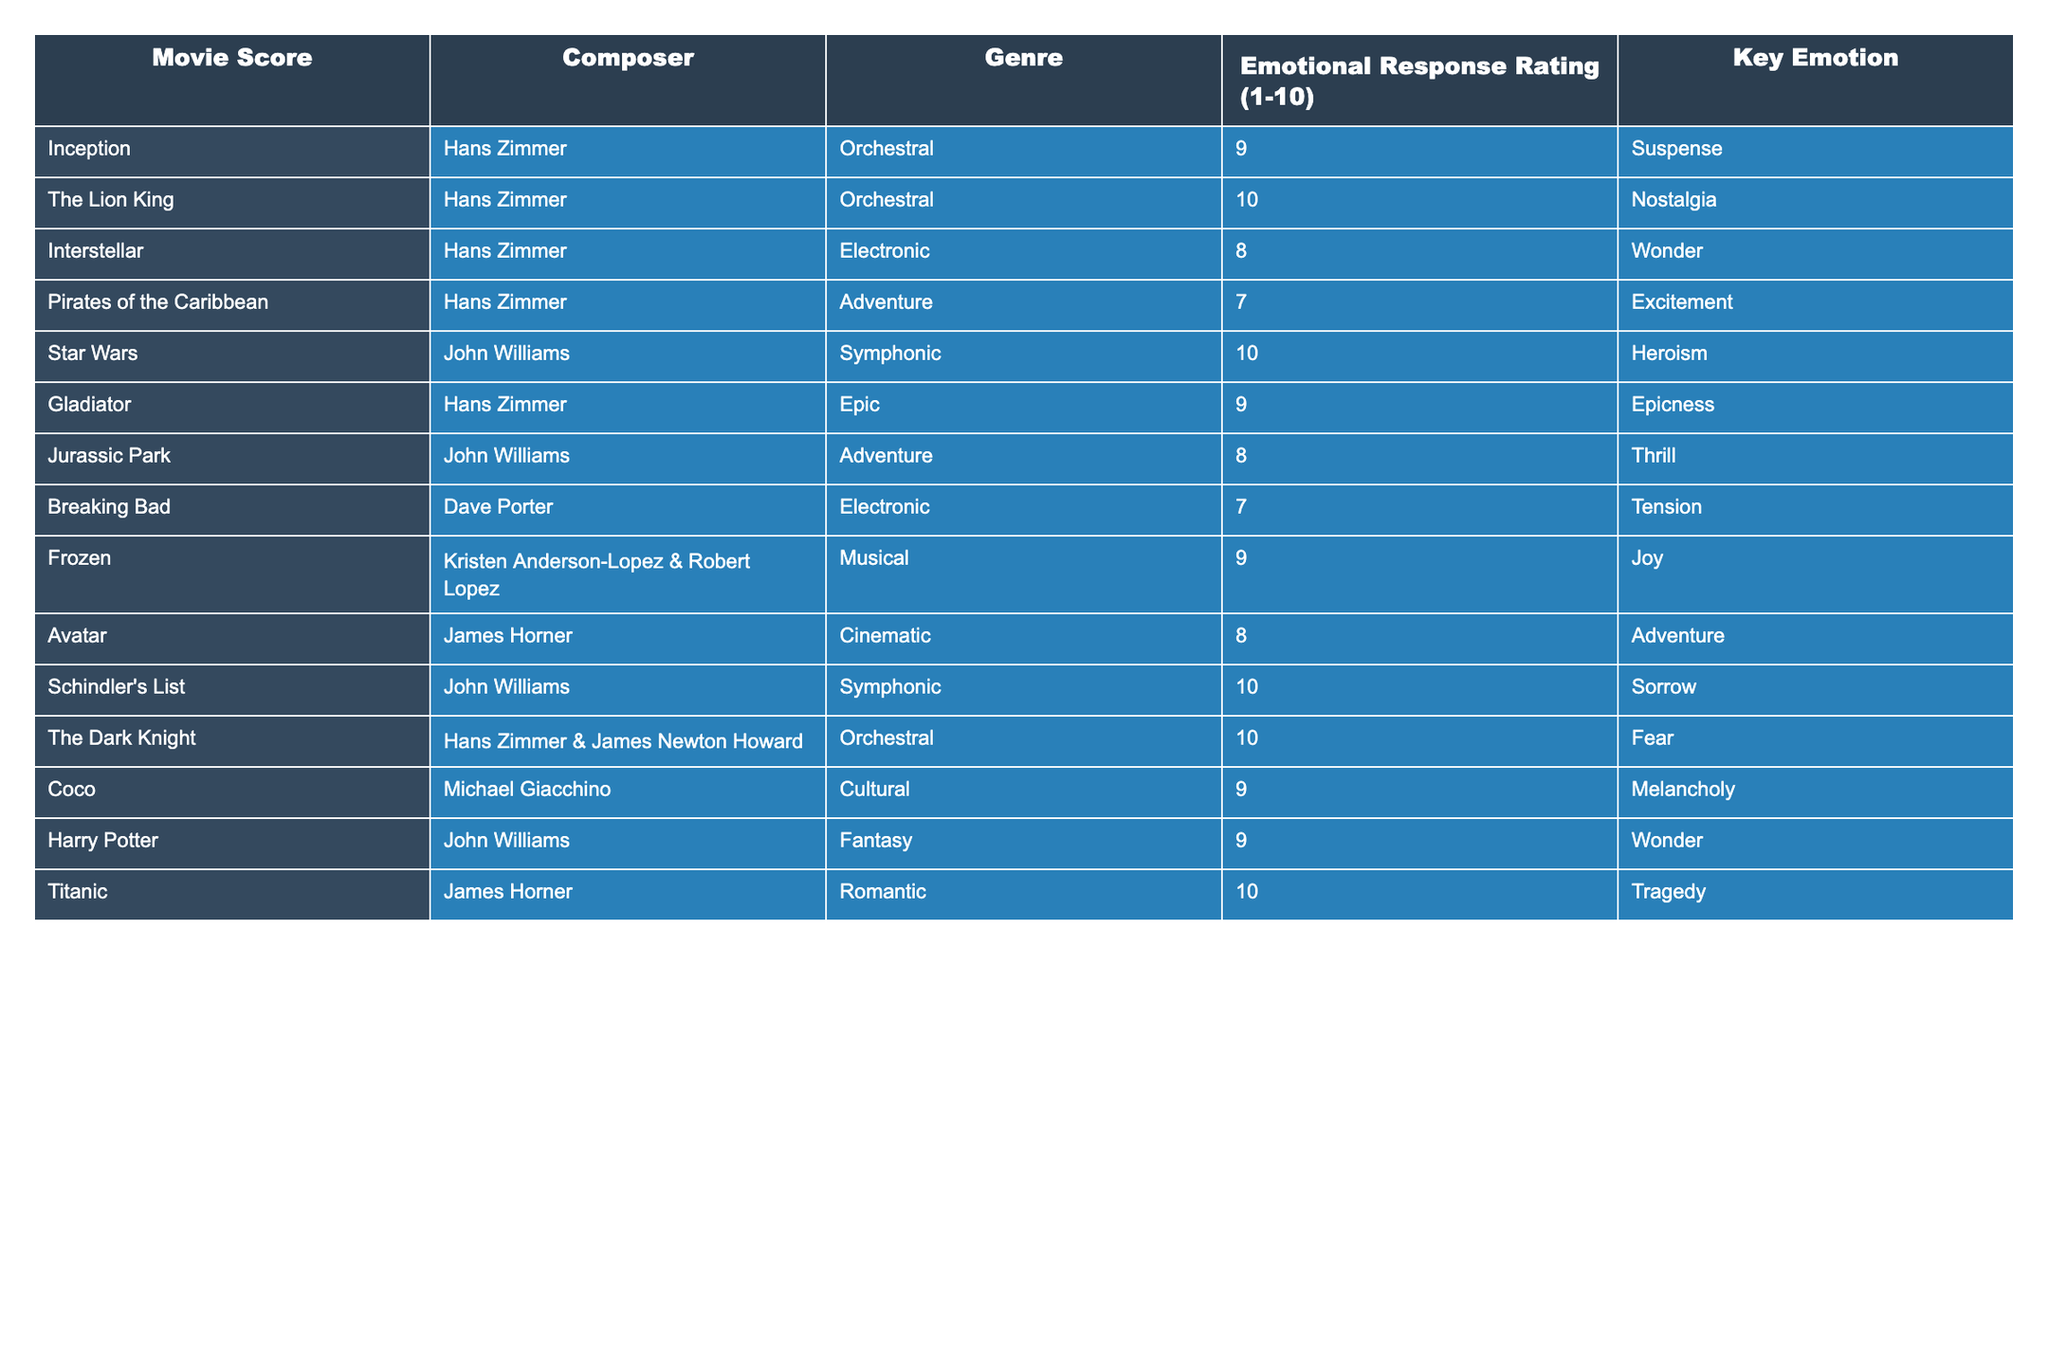What is the emotional response rating of "The Lion King"? The emotional response rating for "The Lion King" is clearly listed in the table. Looking under the column for Emotional Response Rating, I find that the rating is 10.
Answer: 10 Which composer is associated with the score for "Interstellar"? The table shows the composer for "Interstellar" in the corresponding row. Under the Composer column, it notes that Hans Zimmer is the composer for this score.
Answer: Hans Zimmer What is the key emotion associated with the score of "Avatar"? The table provides the Key Emotion for each movie score. For "Avatar," it is listed as Adventure.
Answer: Adventure What is the average emotional response rating for Hans Zimmer's scores? First, I need to identify all scores composed by Hans Zimmer in the table. Those scores are "Inception" (9), "The Lion King" (10), "Interstellar" (8), "Pirates of the Caribbean" (7), "Gladiator" (9), and "The Dark Knight" (10). Adding these ratings gives 9 + 10 + 8 + 7 + 9 + 10 = 53. There are 6 scores in total, so I calculate the average as 53/6 = 8.83.
Answer: 8.83 Is "Schindler's List" rated higher than "Jurassic Park"? To answer this, I refer to the emotional response ratings for both scores in the table. "Schindler's List" has a rating of 10, while "Jurassic Park" has a rating of 8. Since 10 is greater than 8, the answer is yes.
Answer: Yes Which score has the highest emotional response rating and what is that rating? By scanning the Emotional Response Rating column, I see that both "The Lion King" and "Star Wars" have the highest rating of 10.
Answer: "The Lion King" and "Star Wars", 10 How many scores have an emotional response rating of 9 or higher? I will count the scores in the Emotional Response Rating column that are 9 or above. The scores that meet this criterion are "Inception" (9), "The Lion King" (10), "Interstellar" (8, not included), "Pirates of the Caribbean" (7, not included), "Gladiator" (9), "Frozen" (9), "Coco" (9), "Harry Potter" (9), "Schindler's List" (10), and "The Dark Knight" (10). This gives a total of 6 scores.
Answer: 6 Do any scores composed by John Williams have an emotional response rating of 10? I will check the rows associated with John Williams in the table. The scores are "Star Wars" (10) and "Schindler's List" (10). Since both scores have a rating of 10, the answer is yes.
Answer: Yes What is the key emotion of the score with the second-highest emotional response rating? First, I need to find the scores and their ratings, then identify the one that has the second-highest rating. After checking the table, "Star Wars" and "The Lion King" tie for the highest rating (10). The next highest is "The Dark Knight" at 10 that is also tied, thus the result will be 9 for "Gladiator," which is scored for Epicness.
Answer: Epicness 